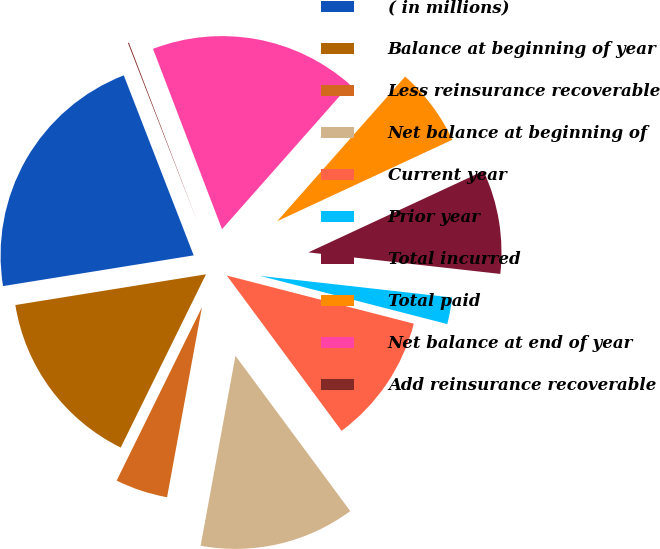Convert chart. <chart><loc_0><loc_0><loc_500><loc_500><pie_chart><fcel>( in millions)<fcel>Balance at beginning of year<fcel>Less reinsurance recoverable<fcel>Net balance at beginning of<fcel>Current year<fcel>Prior year<fcel>Total incurred<fcel>Total paid<fcel>Net balance at end of year<fcel>Add reinsurance recoverable<nl><fcel>21.65%<fcel>15.18%<fcel>4.39%<fcel>13.02%<fcel>10.86%<fcel>2.23%<fcel>8.71%<fcel>6.55%<fcel>17.34%<fcel>0.08%<nl></chart> 